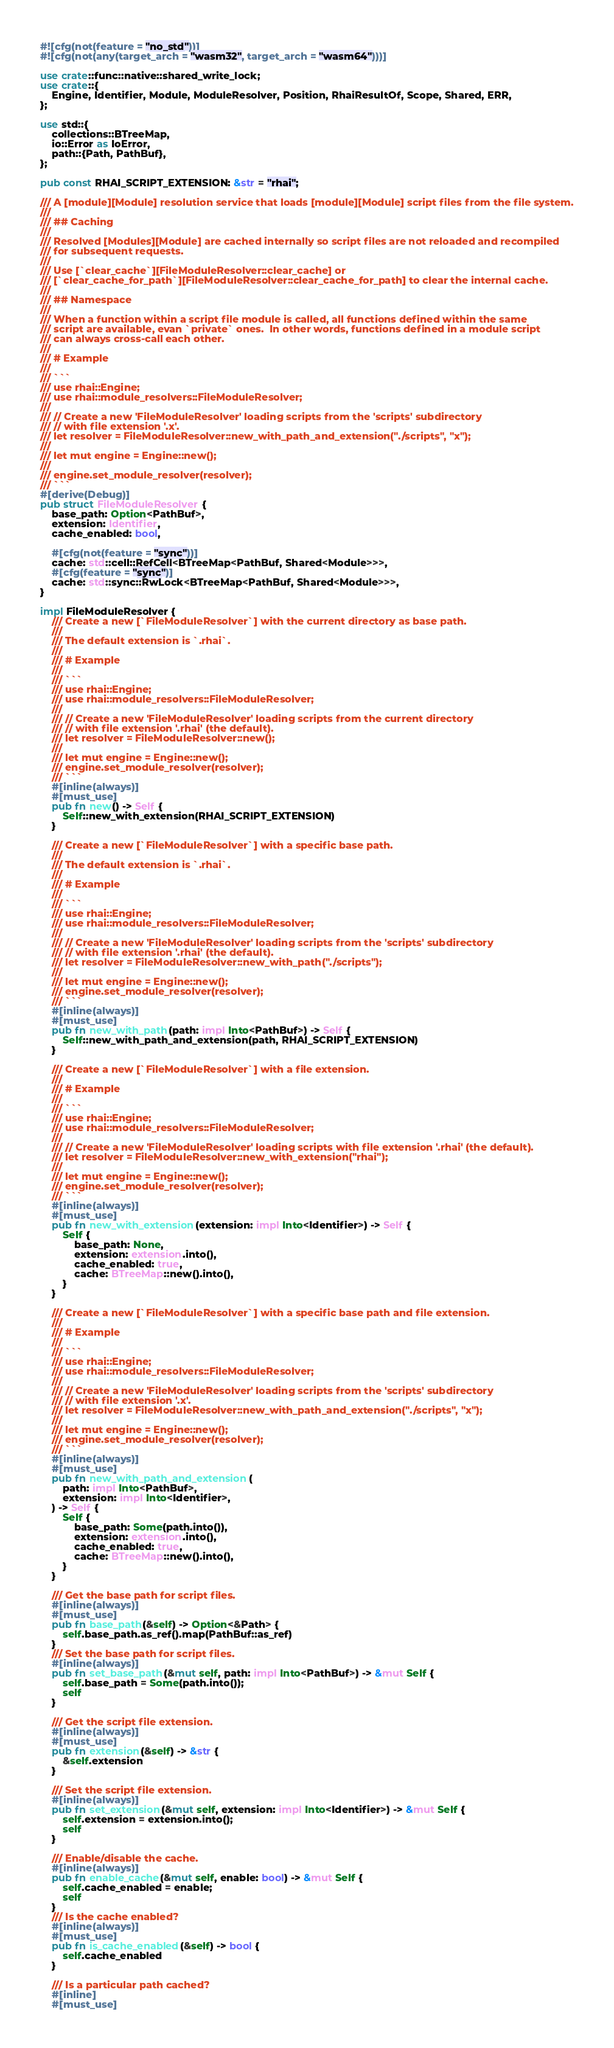Convert code to text. <code><loc_0><loc_0><loc_500><loc_500><_Rust_>#![cfg(not(feature = "no_std"))]
#![cfg(not(any(target_arch = "wasm32", target_arch = "wasm64")))]

use crate::func::native::shared_write_lock;
use crate::{
    Engine, Identifier, Module, ModuleResolver, Position, RhaiResultOf, Scope, Shared, ERR,
};

use std::{
    collections::BTreeMap,
    io::Error as IoError,
    path::{Path, PathBuf},
};

pub const RHAI_SCRIPT_EXTENSION: &str = "rhai";

/// A [module][Module] resolution service that loads [module][Module] script files from the file system.
///
/// ## Caching
///
/// Resolved [Modules][Module] are cached internally so script files are not reloaded and recompiled
/// for subsequent requests.
///
/// Use [`clear_cache`][FileModuleResolver::clear_cache] or
/// [`clear_cache_for_path`][FileModuleResolver::clear_cache_for_path] to clear the internal cache.
///
/// ## Namespace
///
/// When a function within a script file module is called, all functions defined within the same
/// script are available, evan `private` ones.  In other words, functions defined in a module script
/// can always cross-call each other.
///
/// # Example
///
/// ```
/// use rhai::Engine;
/// use rhai::module_resolvers::FileModuleResolver;
///
/// // Create a new 'FileModuleResolver' loading scripts from the 'scripts' subdirectory
/// // with file extension '.x'.
/// let resolver = FileModuleResolver::new_with_path_and_extension("./scripts", "x");
///
/// let mut engine = Engine::new();
///
/// engine.set_module_resolver(resolver);
/// ```
#[derive(Debug)]
pub struct FileModuleResolver {
    base_path: Option<PathBuf>,
    extension: Identifier,
    cache_enabled: bool,

    #[cfg(not(feature = "sync"))]
    cache: std::cell::RefCell<BTreeMap<PathBuf, Shared<Module>>>,
    #[cfg(feature = "sync")]
    cache: std::sync::RwLock<BTreeMap<PathBuf, Shared<Module>>>,
}

impl FileModuleResolver {
    /// Create a new [`FileModuleResolver`] with the current directory as base path.
    ///
    /// The default extension is `.rhai`.
    ///
    /// # Example
    ///
    /// ```
    /// use rhai::Engine;
    /// use rhai::module_resolvers::FileModuleResolver;
    ///
    /// // Create a new 'FileModuleResolver' loading scripts from the current directory
    /// // with file extension '.rhai' (the default).
    /// let resolver = FileModuleResolver::new();
    ///
    /// let mut engine = Engine::new();
    /// engine.set_module_resolver(resolver);
    /// ```
    #[inline(always)]
    #[must_use]
    pub fn new() -> Self {
        Self::new_with_extension(RHAI_SCRIPT_EXTENSION)
    }

    /// Create a new [`FileModuleResolver`] with a specific base path.
    ///
    /// The default extension is `.rhai`.
    ///
    /// # Example
    ///
    /// ```
    /// use rhai::Engine;
    /// use rhai::module_resolvers::FileModuleResolver;
    ///
    /// // Create a new 'FileModuleResolver' loading scripts from the 'scripts' subdirectory
    /// // with file extension '.rhai' (the default).
    /// let resolver = FileModuleResolver::new_with_path("./scripts");
    ///
    /// let mut engine = Engine::new();
    /// engine.set_module_resolver(resolver);
    /// ```
    #[inline(always)]
    #[must_use]
    pub fn new_with_path(path: impl Into<PathBuf>) -> Self {
        Self::new_with_path_and_extension(path, RHAI_SCRIPT_EXTENSION)
    }

    /// Create a new [`FileModuleResolver`] with a file extension.
    ///
    /// # Example
    ///
    /// ```
    /// use rhai::Engine;
    /// use rhai::module_resolvers::FileModuleResolver;
    ///
    /// // Create a new 'FileModuleResolver' loading scripts with file extension '.rhai' (the default).
    /// let resolver = FileModuleResolver::new_with_extension("rhai");
    ///
    /// let mut engine = Engine::new();
    /// engine.set_module_resolver(resolver);
    /// ```
    #[inline(always)]
    #[must_use]
    pub fn new_with_extension(extension: impl Into<Identifier>) -> Self {
        Self {
            base_path: None,
            extension: extension.into(),
            cache_enabled: true,
            cache: BTreeMap::new().into(),
        }
    }

    /// Create a new [`FileModuleResolver`] with a specific base path and file extension.
    ///
    /// # Example
    ///
    /// ```
    /// use rhai::Engine;
    /// use rhai::module_resolvers::FileModuleResolver;
    ///
    /// // Create a new 'FileModuleResolver' loading scripts from the 'scripts' subdirectory
    /// // with file extension '.x'.
    /// let resolver = FileModuleResolver::new_with_path_and_extension("./scripts", "x");
    ///
    /// let mut engine = Engine::new();
    /// engine.set_module_resolver(resolver);
    /// ```
    #[inline(always)]
    #[must_use]
    pub fn new_with_path_and_extension(
        path: impl Into<PathBuf>,
        extension: impl Into<Identifier>,
    ) -> Self {
        Self {
            base_path: Some(path.into()),
            extension: extension.into(),
            cache_enabled: true,
            cache: BTreeMap::new().into(),
        }
    }

    /// Get the base path for script files.
    #[inline(always)]
    #[must_use]
    pub fn base_path(&self) -> Option<&Path> {
        self.base_path.as_ref().map(PathBuf::as_ref)
    }
    /// Set the base path for script files.
    #[inline(always)]
    pub fn set_base_path(&mut self, path: impl Into<PathBuf>) -> &mut Self {
        self.base_path = Some(path.into());
        self
    }

    /// Get the script file extension.
    #[inline(always)]
    #[must_use]
    pub fn extension(&self) -> &str {
        &self.extension
    }

    /// Set the script file extension.
    #[inline(always)]
    pub fn set_extension(&mut self, extension: impl Into<Identifier>) -> &mut Self {
        self.extension = extension.into();
        self
    }

    /// Enable/disable the cache.
    #[inline(always)]
    pub fn enable_cache(&mut self, enable: bool) -> &mut Self {
        self.cache_enabled = enable;
        self
    }
    /// Is the cache enabled?
    #[inline(always)]
    #[must_use]
    pub fn is_cache_enabled(&self) -> bool {
        self.cache_enabled
    }

    /// Is a particular path cached?
    #[inline]
    #[must_use]</code> 